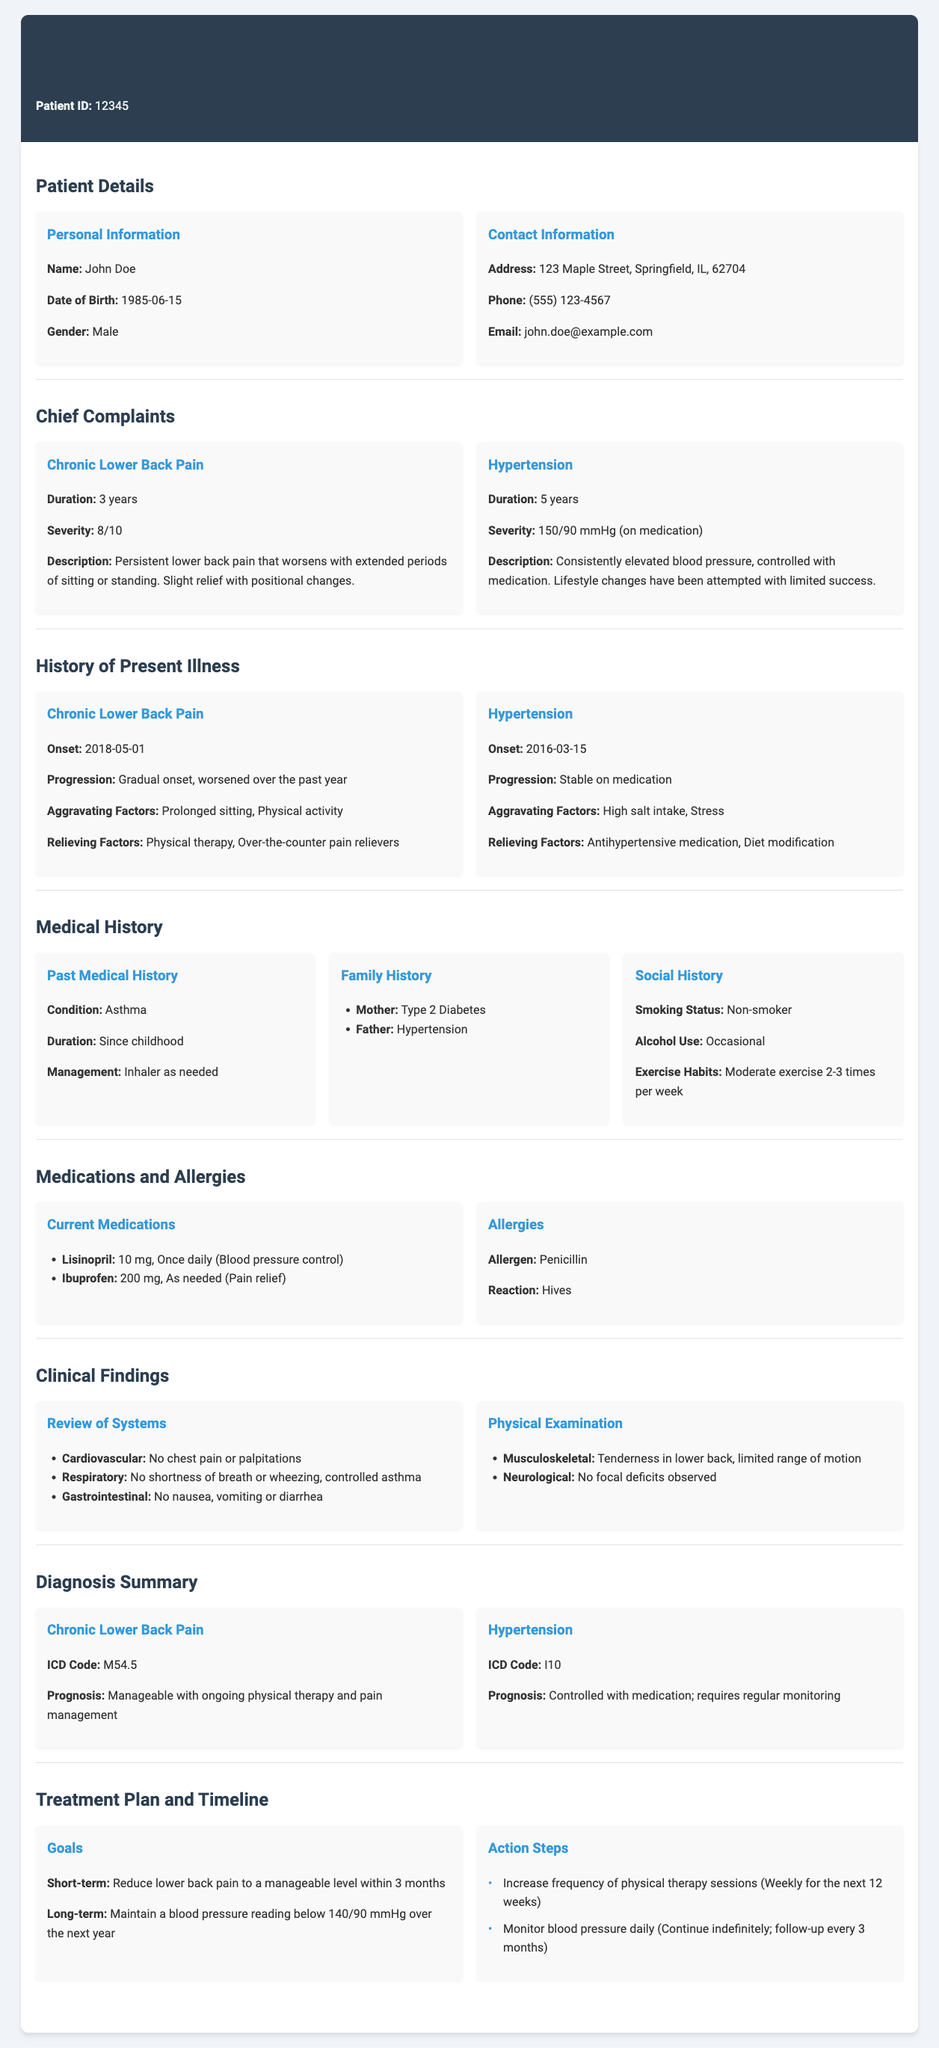What is the patient's name? The patient's name is provided in the personal information section of the document.
Answer: John Doe When was the onset of chronic lower back pain? The onset date can be found in the history of present illness section.
Answer: 2018-05-01 What is the current medication for hypertension? The medication for hypertension is listed under medications and allergies.
Answer: Lisinopril What is the ICD code for hypertension? The ICD code for hypertension is mentioned in the diagnosis summary section.
Answer: I10 What is the prognosis for chronic lower back pain? The prognosis is described in the diagnosis summary for chronic lower back pain.
Answer: Manageable with ongoing physical therapy and pain management What lifestyle change has been attempted for hypertension? The lifestyle change attempted is mentioned in relation to hypertension management.
Answer: Diet modification How long has the patient experienced chronic lower back pain? The duration of chronic lower back pain is specified in the chief complaints section.
Answer: 3 years What is the short-term goal in the treatment plan? The short-term goal is outlined in the treatment plan and can be found in that section.
Answer: Reduce lower back pain to a manageable level within 3 months What are the aggravating factors for chronic lower back pain? This information is provided under the history of the present illness for chronic lower back pain.
Answer: Prolonged sitting, Physical activity 